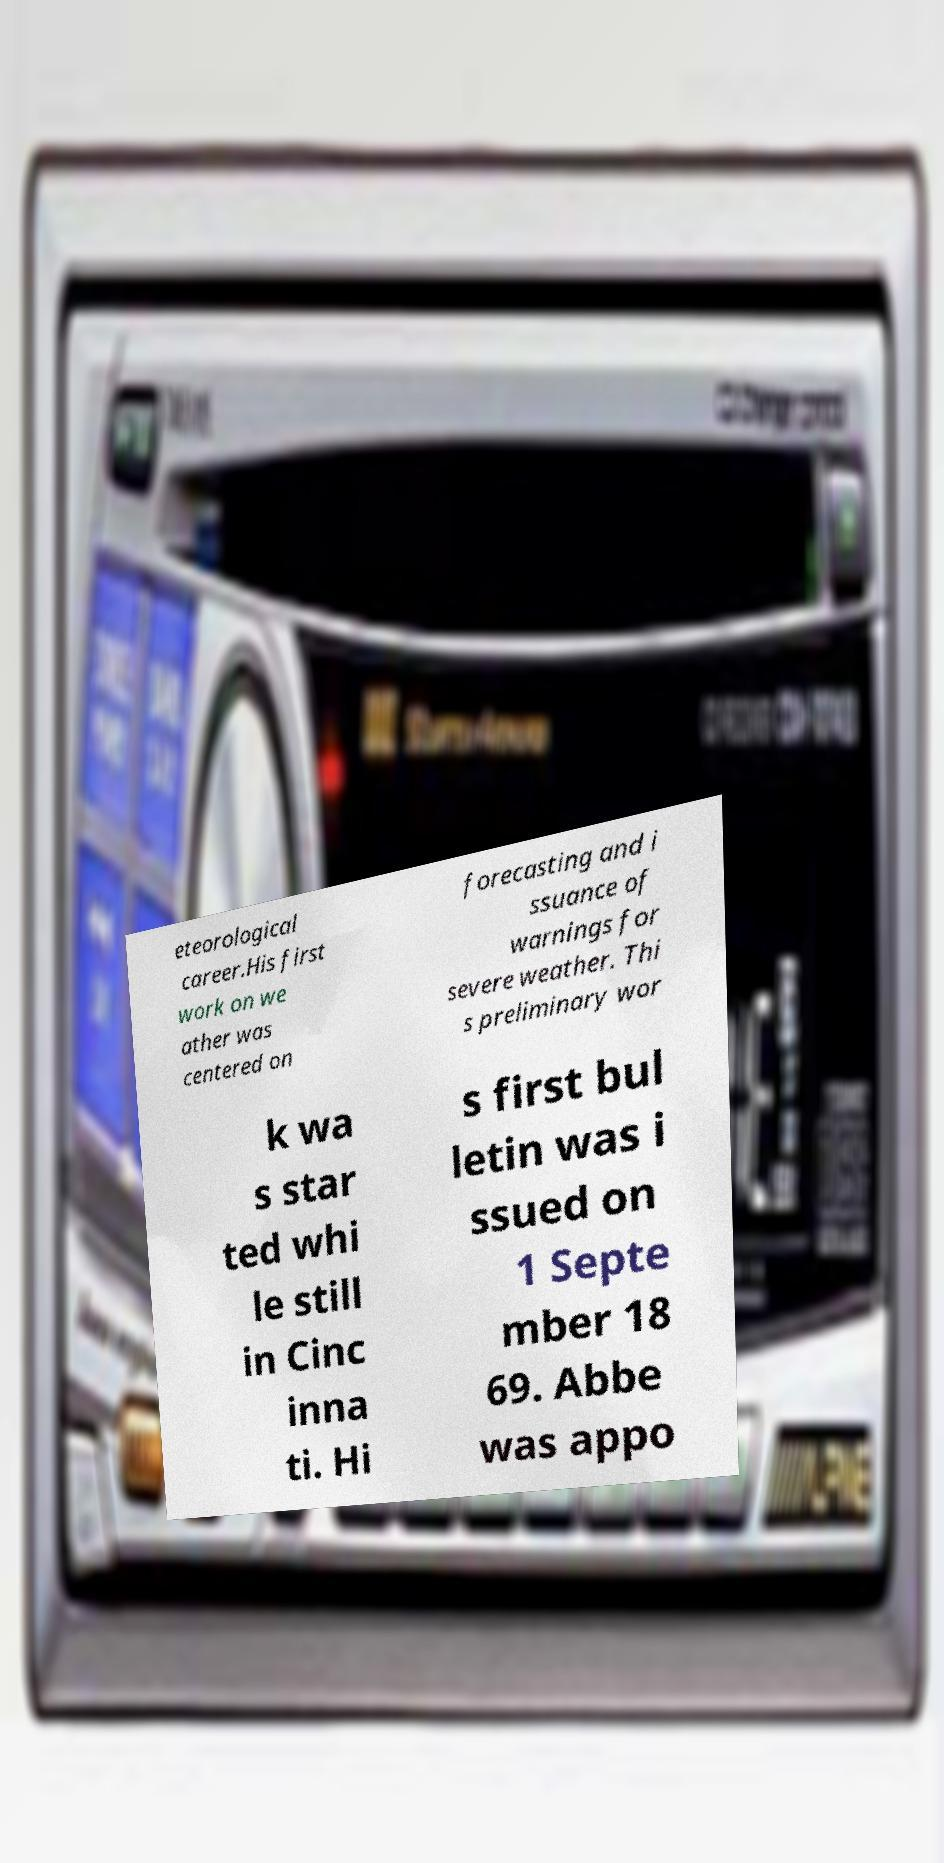Could you extract and type out the text from this image? eteorological career.His first work on we ather was centered on forecasting and i ssuance of warnings for severe weather. Thi s preliminary wor k wa s star ted whi le still in Cinc inna ti. Hi s first bul letin was i ssued on 1 Septe mber 18 69. Abbe was appo 